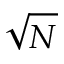Convert formula to latex. <formula><loc_0><loc_0><loc_500><loc_500>\sqrt { N }</formula> 